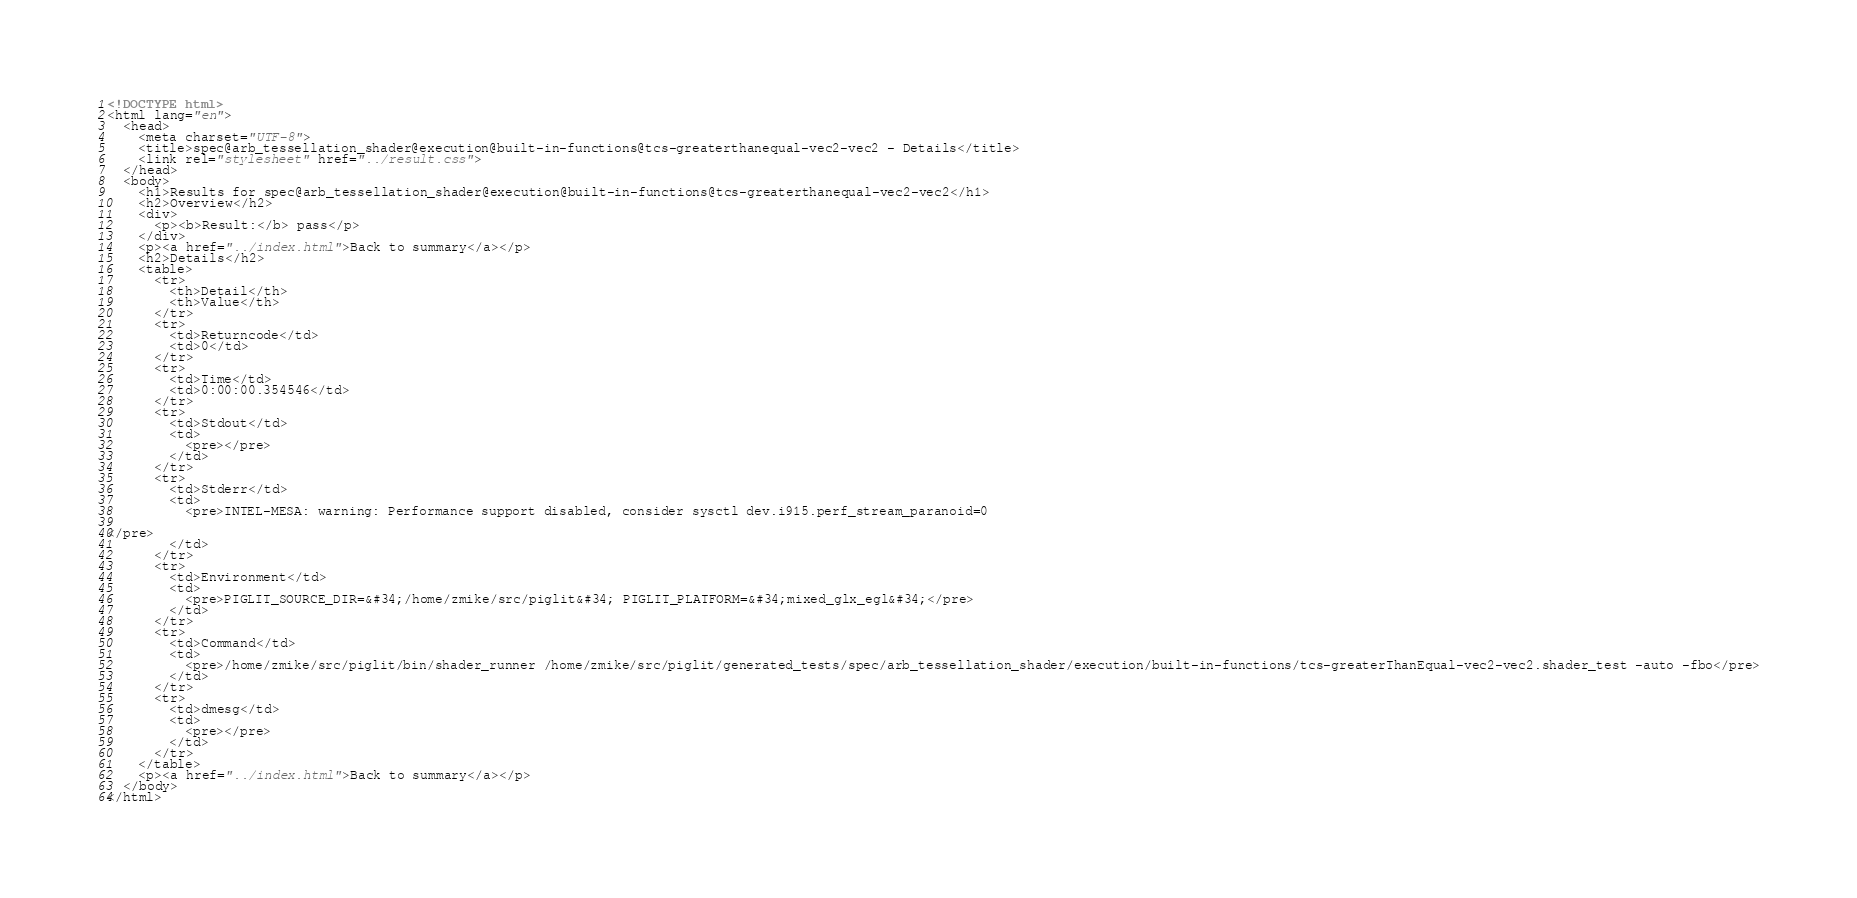Convert code to text. <code><loc_0><loc_0><loc_500><loc_500><_HTML_><!DOCTYPE html>
<html lang="en">
  <head>
    <meta charset="UTF-8">
    <title>spec@arb_tessellation_shader@execution@built-in-functions@tcs-greaterthanequal-vec2-vec2 - Details</title>
    <link rel="stylesheet" href="../result.css">
  </head>
  <body>
    <h1>Results for spec@arb_tessellation_shader@execution@built-in-functions@tcs-greaterthanequal-vec2-vec2</h1>
    <h2>Overview</h2>
    <div>
      <p><b>Result:</b> pass</p>
    </div>
    <p><a href="../index.html">Back to summary</a></p>
    <h2>Details</h2>
    <table>
      <tr>
        <th>Detail</th>
        <th>Value</th>
      </tr>
      <tr>
        <td>Returncode</td>
        <td>0</td>
      </tr>
      <tr>
        <td>Time</td>
        <td>0:00:00.354546</td>
      </tr>
      <tr>
        <td>Stdout</td>
        <td>
          <pre></pre>
        </td>
      </tr>
      <tr>
        <td>Stderr</td>
        <td>
          <pre>INTEL-MESA: warning: Performance support disabled, consider sysctl dev.i915.perf_stream_paranoid=0

</pre>
        </td>
      </tr>
      <tr>
        <td>Environment</td>
        <td>
          <pre>PIGLIT_SOURCE_DIR=&#34;/home/zmike/src/piglit&#34; PIGLIT_PLATFORM=&#34;mixed_glx_egl&#34;</pre>
        </td>
      </tr>
      <tr>
        <td>Command</td>
        <td>
          <pre>/home/zmike/src/piglit/bin/shader_runner /home/zmike/src/piglit/generated_tests/spec/arb_tessellation_shader/execution/built-in-functions/tcs-greaterThanEqual-vec2-vec2.shader_test -auto -fbo</pre>
        </td>
      </tr>
      <tr>
        <td>dmesg</td>
        <td>
          <pre></pre>
        </td>
      </tr>
    </table>
    <p><a href="../index.html">Back to summary</a></p>
  </body>
</html>
</code> 